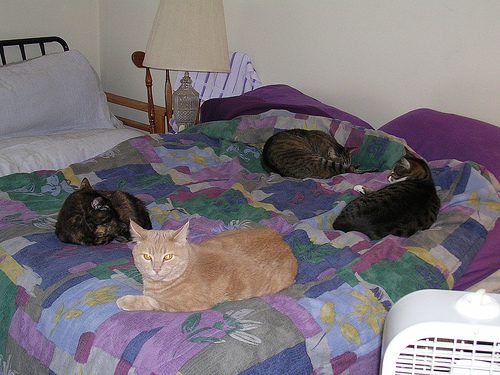<image>
Can you confirm if the cat is on the bed? Yes. Looking at the image, I can see the cat is positioned on top of the bed, with the bed providing support. Where is the cat in relation to the cat? Is it behind the cat? No. The cat is not behind the cat. From this viewpoint, the cat appears to be positioned elsewhere in the scene. 